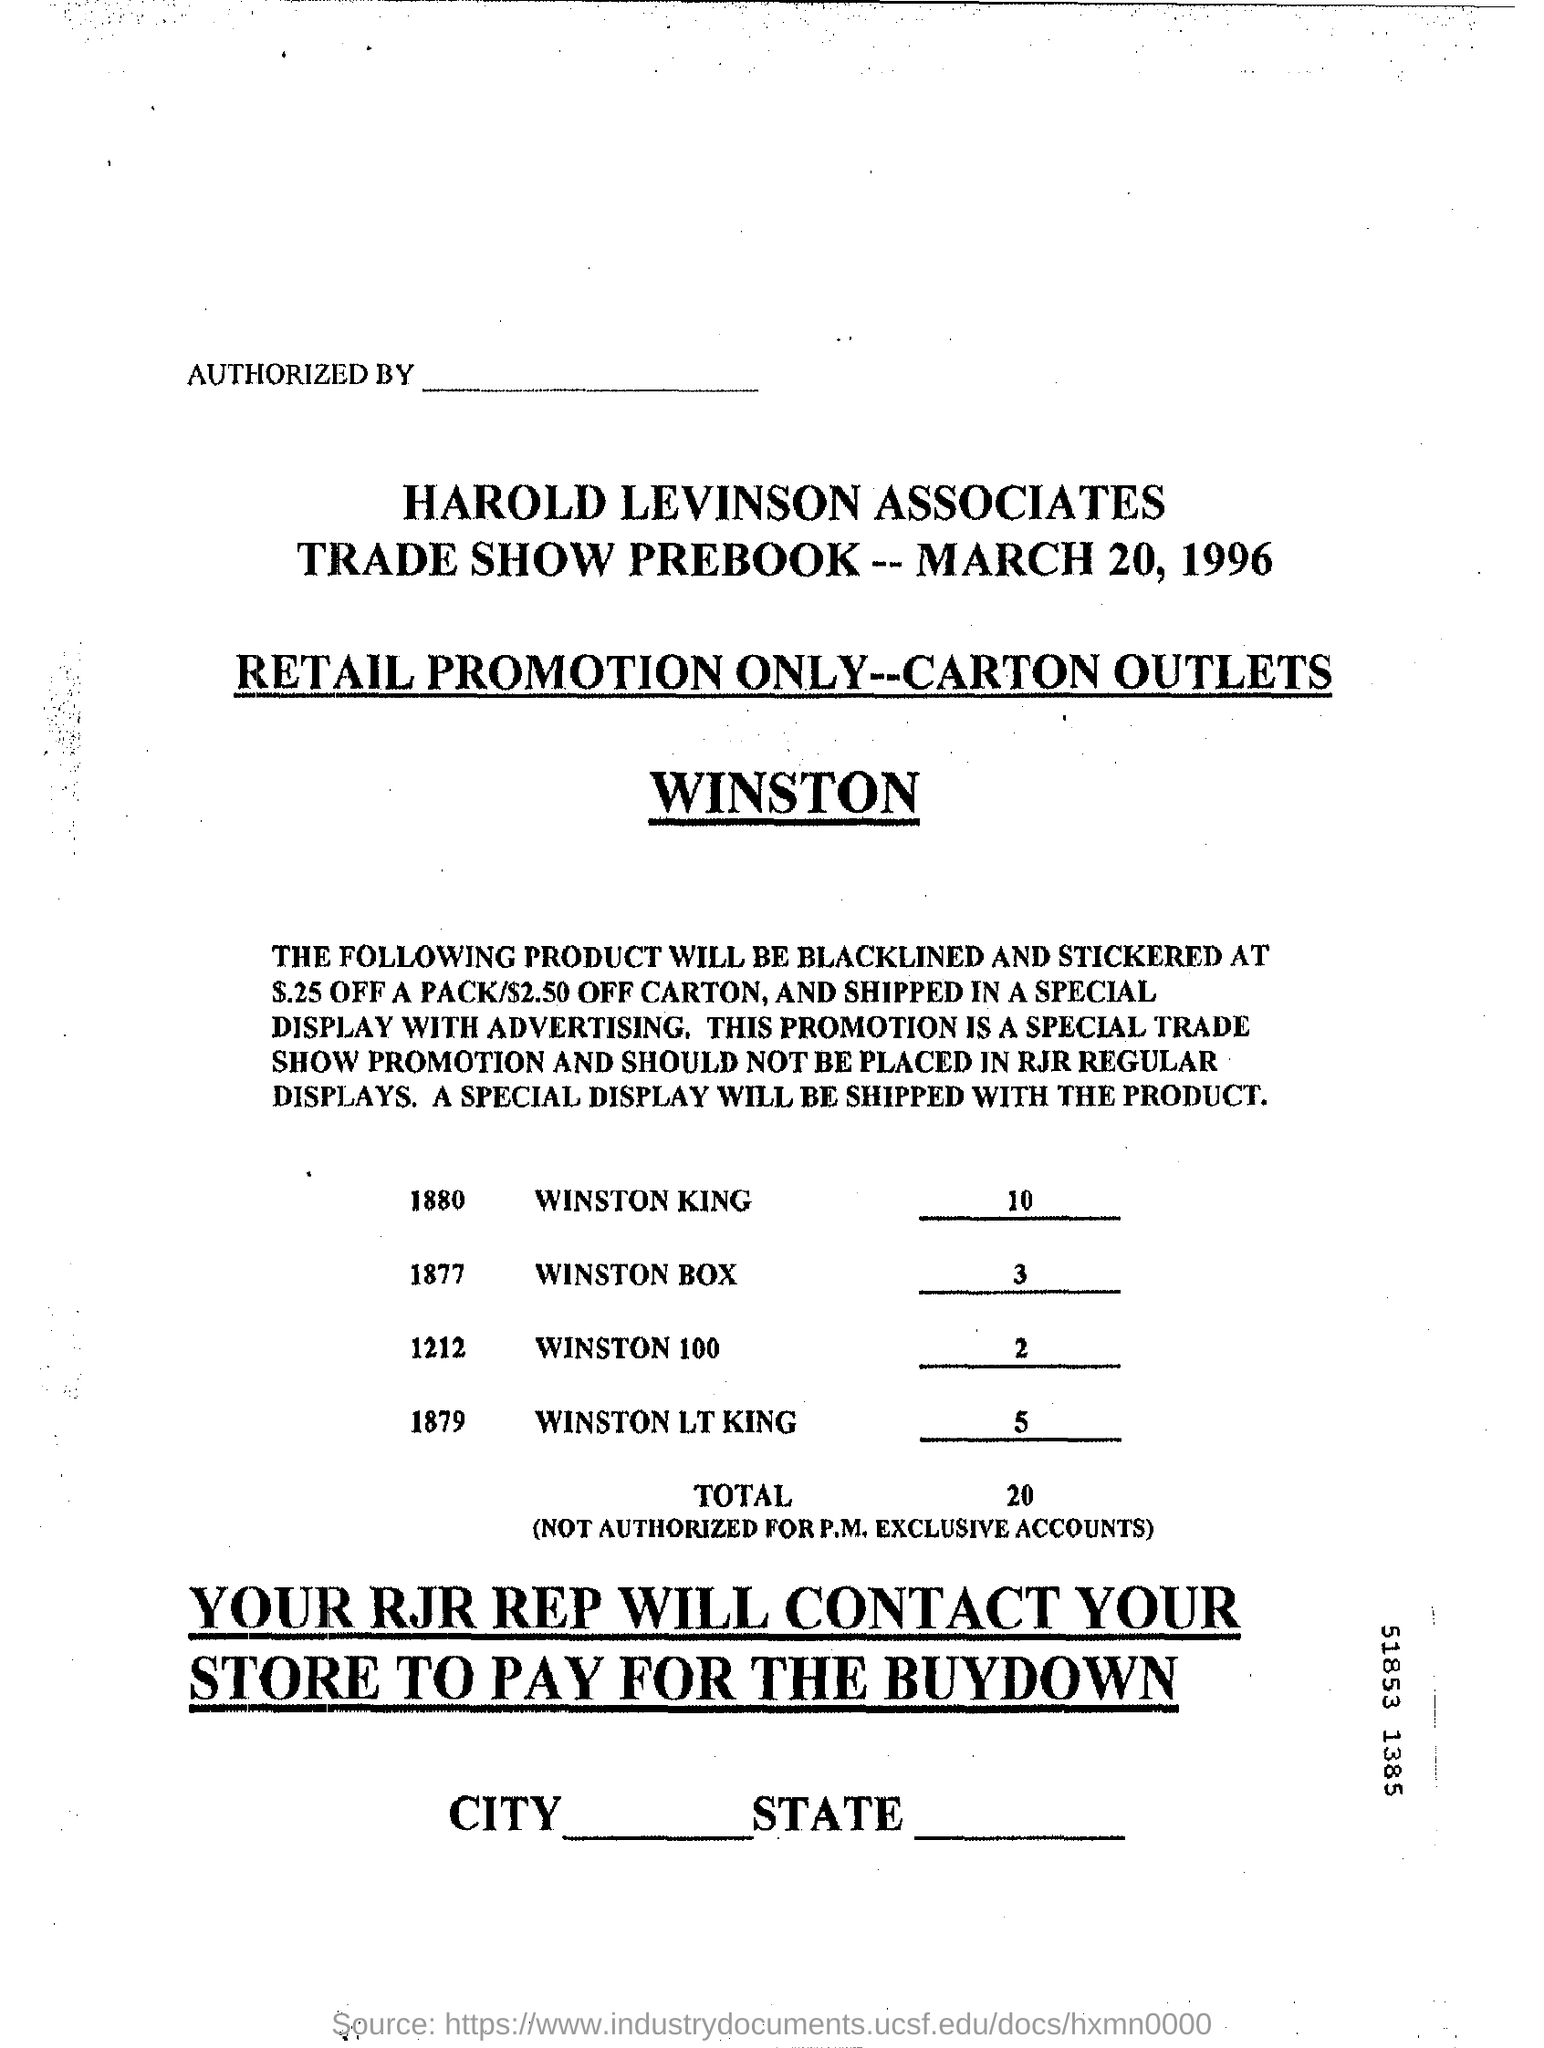Give some essential details in this illustration. The date on the document is March 20, 1996. 